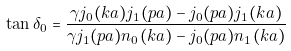<formula> <loc_0><loc_0><loc_500><loc_500>\tan \delta _ { 0 } = \frac { \gamma j _ { 0 } ( k a ) j _ { 1 } ( p a ) - j _ { 0 } ( p a ) j _ { 1 } ( k a ) } { \gamma j _ { 1 } ( p a ) n _ { 0 } ( k a ) - j _ { 0 } ( p a ) n _ { 1 } ( k a ) }</formula> 